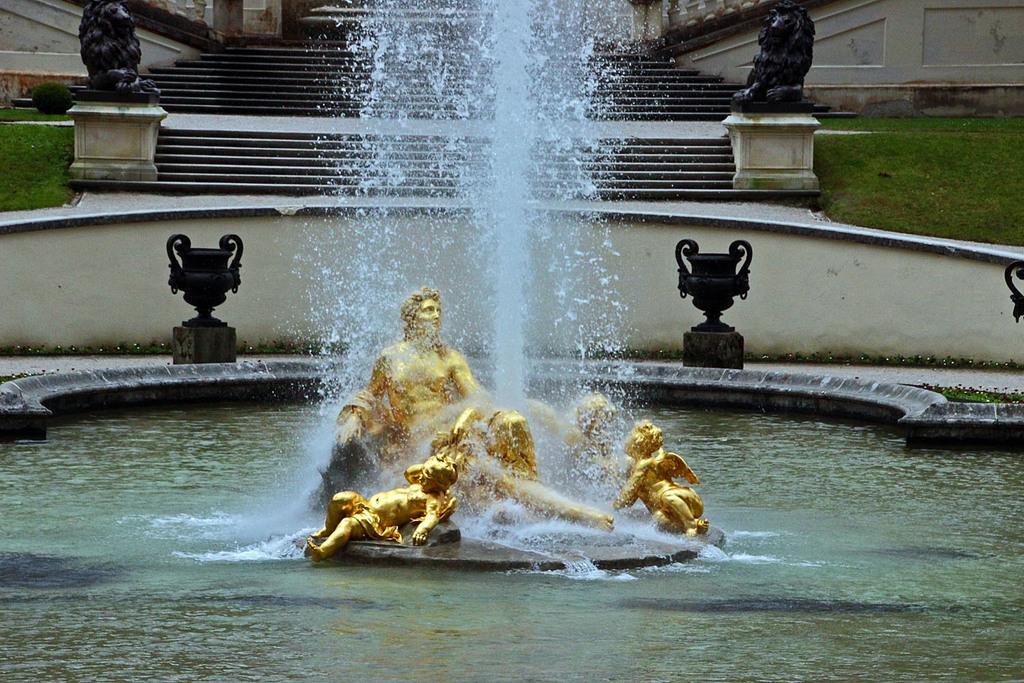How would you summarize this image in a sentence or two? In the image I can see a water fountain which has some statues around and behind there are some lights and stair case. 